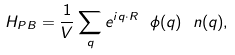<formula> <loc_0><loc_0><loc_500><loc_500>H _ { P B } = { \frac { 1 } { V } } \sum _ { q } e ^ { i { q } \cdot { R } } \ \phi ( { q } ) \ n ( { q } ) ,</formula> 